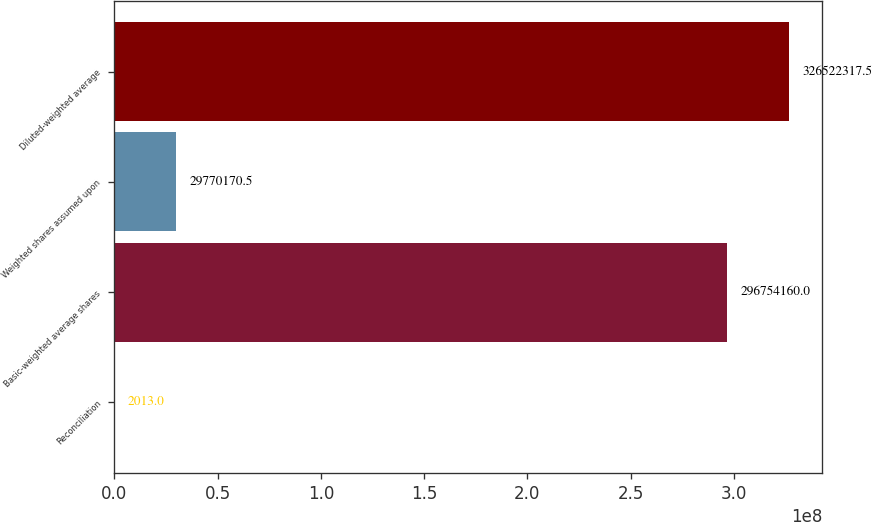Convert chart to OTSL. <chart><loc_0><loc_0><loc_500><loc_500><bar_chart><fcel>Reconciliation<fcel>Basic-weighted average shares<fcel>Weighted shares assumed upon<fcel>Diluted-weighted average<nl><fcel>2013<fcel>2.96754e+08<fcel>2.97702e+07<fcel>3.26522e+08<nl></chart> 